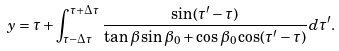<formula> <loc_0><loc_0><loc_500><loc_500>y = \tau + \int _ { \tau - \Delta \tau } ^ { \tau + \Delta \tau } \frac { \sin ( \tau ^ { \prime } - \tau ) } { \tan \beta \sin \beta _ { 0 } + \cos \beta _ { 0 } \cos ( \tau ^ { \prime } - \tau ) } d \tau ^ { \prime } .</formula> 